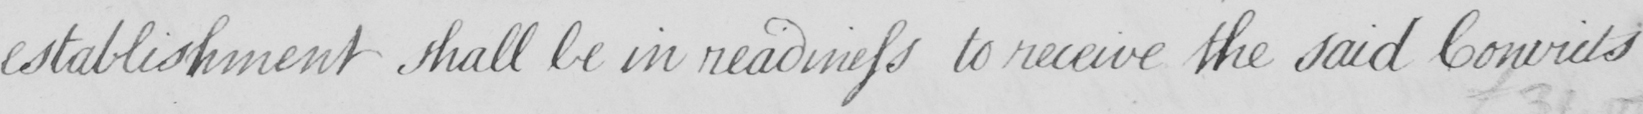Can you tell me what this handwritten text says? establishment shall be in readiness to receive the said Convicts 